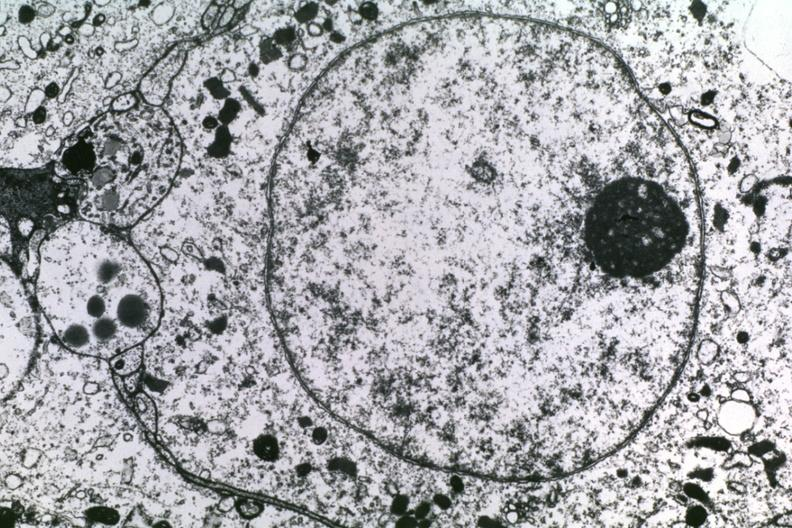what is present?
Answer the question using a single word or phrase. Brain 